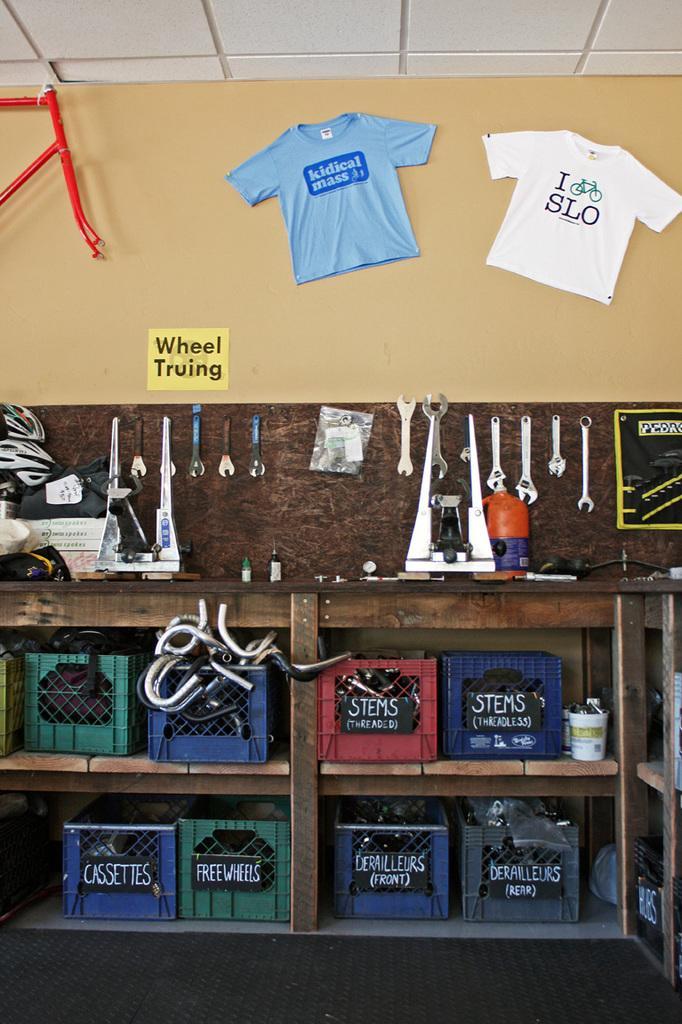Please provide a concise description of this image. In this image in the center there is a wooden table, and under the table there are some baskets. And in the basket there are some objects and also there are some cups, and in the center there are some instruments, board, wire and some objects and there are two t-shirts board and some object on the wall. At the top there is ceiling, and at the bottom there is floor and carpet. 